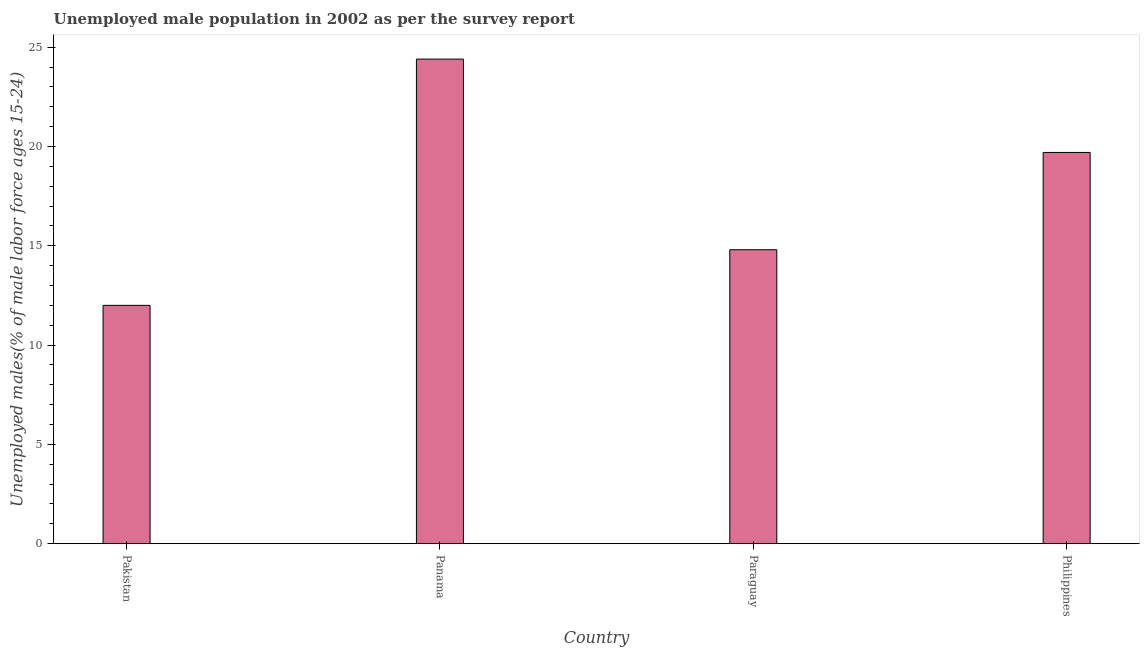Does the graph contain any zero values?
Your response must be concise. No. Does the graph contain grids?
Offer a very short reply. No. What is the title of the graph?
Your answer should be compact. Unemployed male population in 2002 as per the survey report. What is the label or title of the X-axis?
Make the answer very short. Country. What is the label or title of the Y-axis?
Provide a short and direct response. Unemployed males(% of male labor force ages 15-24). What is the unemployed male youth in Pakistan?
Provide a succinct answer. 12. Across all countries, what is the maximum unemployed male youth?
Provide a short and direct response. 24.4. In which country was the unemployed male youth maximum?
Offer a very short reply. Panama. In which country was the unemployed male youth minimum?
Provide a succinct answer. Pakistan. What is the sum of the unemployed male youth?
Ensure brevity in your answer.  70.9. What is the difference between the unemployed male youth in Panama and Paraguay?
Provide a short and direct response. 9.6. What is the average unemployed male youth per country?
Your answer should be compact. 17.73. What is the median unemployed male youth?
Make the answer very short. 17.25. What is the ratio of the unemployed male youth in Pakistan to that in Paraguay?
Offer a terse response. 0.81. Is the unemployed male youth in Panama less than that in Philippines?
Offer a very short reply. No. Is the sum of the unemployed male youth in Pakistan and Philippines greater than the maximum unemployed male youth across all countries?
Give a very brief answer. Yes. What is the difference between the highest and the lowest unemployed male youth?
Offer a terse response. 12.4. In how many countries, is the unemployed male youth greater than the average unemployed male youth taken over all countries?
Your answer should be very brief. 2. How many bars are there?
Provide a succinct answer. 4. Are all the bars in the graph horizontal?
Your response must be concise. No. How many countries are there in the graph?
Offer a terse response. 4. What is the difference between two consecutive major ticks on the Y-axis?
Give a very brief answer. 5. What is the Unemployed males(% of male labor force ages 15-24) in Panama?
Keep it short and to the point. 24.4. What is the Unemployed males(% of male labor force ages 15-24) of Paraguay?
Keep it short and to the point. 14.8. What is the Unemployed males(% of male labor force ages 15-24) of Philippines?
Provide a succinct answer. 19.7. What is the difference between the Unemployed males(% of male labor force ages 15-24) in Pakistan and Panama?
Keep it short and to the point. -12.4. What is the difference between the Unemployed males(% of male labor force ages 15-24) in Paraguay and Philippines?
Your answer should be very brief. -4.9. What is the ratio of the Unemployed males(% of male labor force ages 15-24) in Pakistan to that in Panama?
Provide a succinct answer. 0.49. What is the ratio of the Unemployed males(% of male labor force ages 15-24) in Pakistan to that in Paraguay?
Keep it short and to the point. 0.81. What is the ratio of the Unemployed males(% of male labor force ages 15-24) in Pakistan to that in Philippines?
Provide a succinct answer. 0.61. What is the ratio of the Unemployed males(% of male labor force ages 15-24) in Panama to that in Paraguay?
Ensure brevity in your answer.  1.65. What is the ratio of the Unemployed males(% of male labor force ages 15-24) in Panama to that in Philippines?
Give a very brief answer. 1.24. What is the ratio of the Unemployed males(% of male labor force ages 15-24) in Paraguay to that in Philippines?
Give a very brief answer. 0.75. 